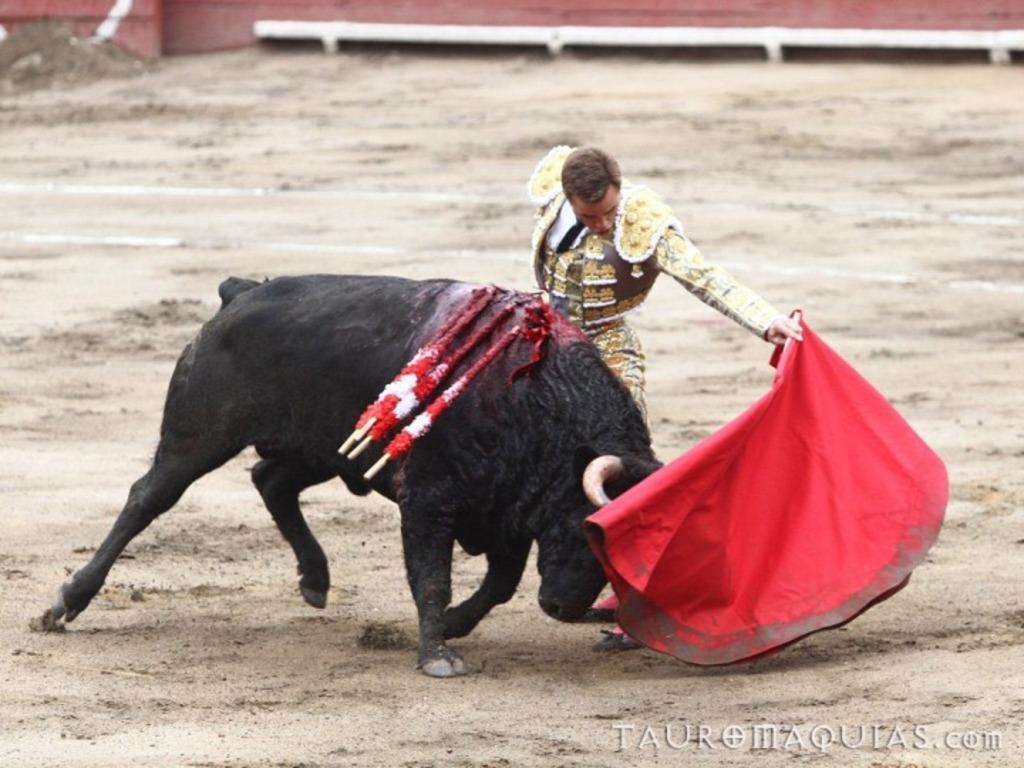Can you describe this image briefly? In the center of the image we can see one bull, which is in black color. And we can see one man standing and holding one red cloth and he is in different costume. On the bull, we can see some objects. In the bottom right side of the image, we can see some text. In the background there is a wall and a few other objects. 